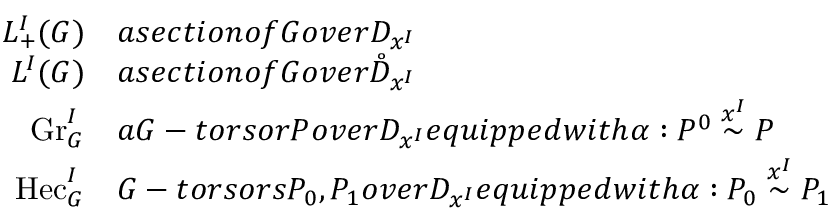<formula> <loc_0><loc_0><loc_500><loc_500>\begin{array} { r l } { L _ { + } ^ { I } ( G ) } & { a s e c t i o n o f G o v e r D _ { x ^ { I } } } \\ { L ^ { I } ( G ) } & { a s e c t i o n o f G o v e r \mathring { D } _ { x ^ { I } } } \\ { G r _ { G } ^ { I } } & { a G - t o r s o r P o v e r D _ { x ^ { I } } e q u i p p e d w i t h \alpha \colon P ^ { 0 } \overset { x ^ { I } } { \sim } P } \\ { H e c _ { G } ^ { I } } & { G - t o r s o r s P _ { 0 } , P _ { 1 } o v e r D _ { x ^ { I } } e q u i p p e d w i t h \alpha \colon P _ { 0 } \overset { x ^ { I } } { \sim } P _ { 1 } } \end{array}</formula> 